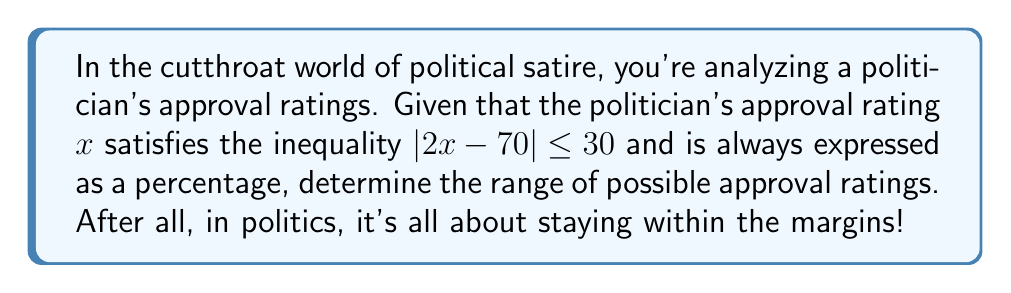Can you answer this question? Let's approach this step-by-step:

1) We start with the inequality $|2x - 70| \leq 30$

2) This can be rewritten as two separate inequalities:
   $-30 \leq 2x - 70 \leq 30$

3) Let's solve both sides:
   For the left side: $-30 \leq 2x - 70$
   Add 70 to both sides: $40 \leq 2x$
   Divide by 2: $20 \leq x$

   For the right side: $2x - 70 \leq 30$
   Add 70 to both sides: $2x \leq 100$
   Divide by 2: $x \leq 50$

4) Combining these results, we get: $20 \leq x \leq 50$

5) However, we need to consider that approval ratings are always expressed as percentages. This means that the lower bound of 20% is valid, but we need to check if 50% is the actual upper bound.

6) Plugging 50% into our original inequality:
   $|2(50) - 70| \leq 30$
   $|100 - 70| \leq 30$
   $30 \leq 30$
   This checks out, so 50% is indeed our upper bound.

Therefore, the range of possible approval ratings is from 20% to 50%.
Answer: $[20\%, 50\%]$ 